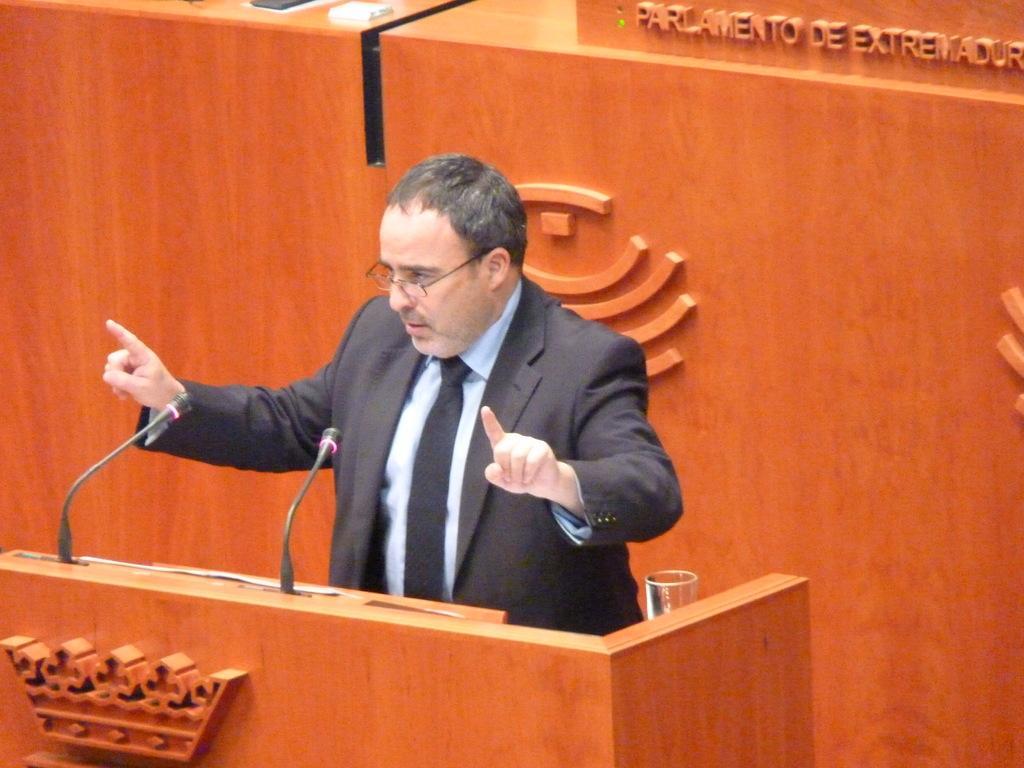How would you summarize this image in a sentence or two? In this picture there is a man in the center of the image and there are two mics and a desk in front of him. 